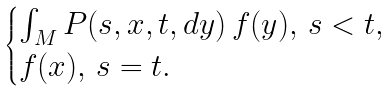<formula> <loc_0><loc_0><loc_500><loc_500>\begin{cases} \int _ { M } P ( s , x , t , d y ) \, f ( y ) , \, s < t , \\ f ( x ) , \, s = t . \end{cases}</formula> 